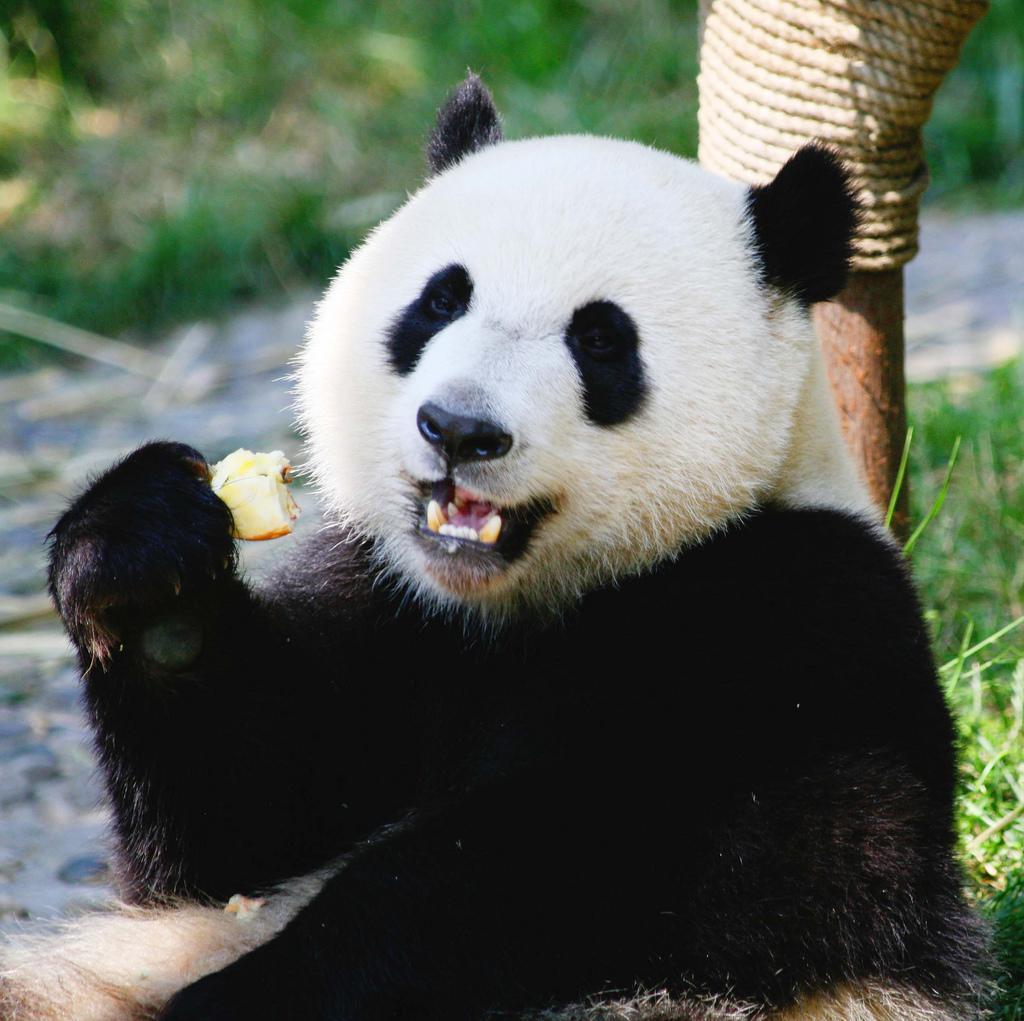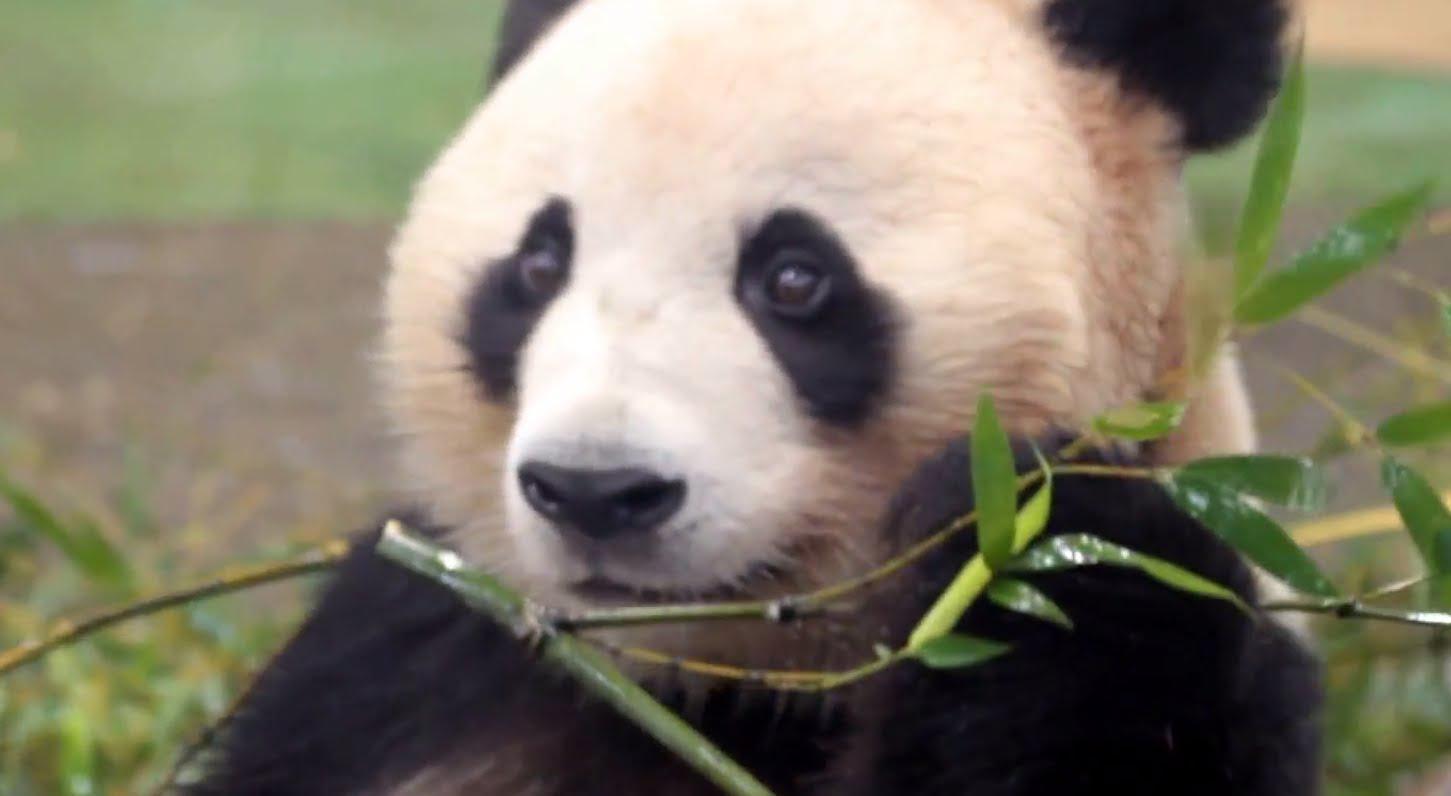The first image is the image on the left, the second image is the image on the right. Evaluate the accuracy of this statement regarding the images: "The panda in the image on the left is sitting near an upright post.". Is it true? Answer yes or no. Yes. The first image is the image on the left, the second image is the image on the right. For the images shown, is this caption "The panda on the left is looking toward the camera and holding a roundish-shaped food near its mouth." true? Answer yes or no. Yes. 